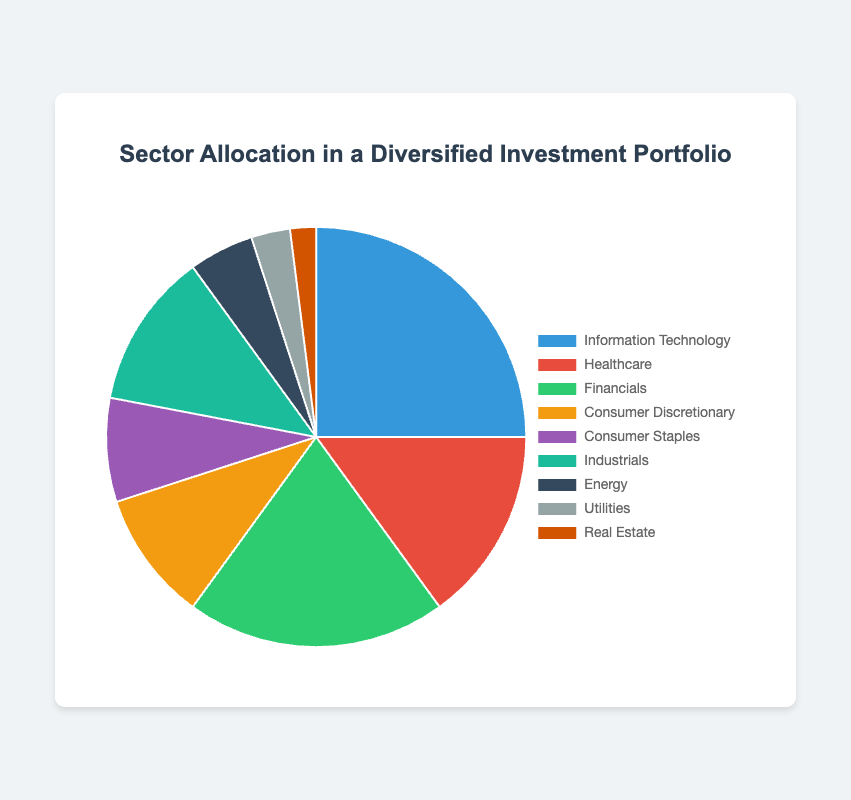What is the sector with the highest allocation percentage? The sector with the highest allocation percentage can be identified by looking at the largest segment in the pie chart. "Information Technology" has the largest slice, indicating 25%.
Answer: Information Technology Which sectors together make up more than 50% of the portfolio? Summing the top sectors by their allocation percentages: Information Technology (25%) + Financials (20%) + Healthcare (15%) = 60%. This sum surpasses 50%, indicating these three sectors together make up more than half of the portfolio.
Answer: Information Technology, Financials, Healthcare What is the difference in allocation between Consumer Discretionary and Consumer Staples? Subtract the allocation percentage of Consumer Staples (8%) from Consumer Discretionary (10%) to find the difference: 10% - 8% = 2%.
Answer: 2% Compare the allocation percentages of Energy and Utilities. Which one is higher and by how much? Energy has an allocation percentage of 5%, and Utilities has 3%. Subtracting the two: 5% - 3% = 2%. Energy has a higher allocation by 2%.
Answer: Energy by 2% What is the total allocation percentage for sectors under 10%? Identifying sectors with allocation percentages under 10% and summing them: Consumer Discretionary (10%) + Consumer Staples (8%) + Energy (5%) + Utilities (3%) + Real Estate (2%) = 10% + 8% + 5% + 3% + 2% = 28%.
Answer: 28% What is the combined allocation percentage of Industrials and Real Estate? Add the allocation percentages of Industrials (12%) and Real Estate (2%): 12% + 2% = 14%.
Answer: 14% Which sector has the smallest allocation and what is its percentage? The smallest sector can be identified by finding the smallest segment in the pie chart. "Real Estate" has the smallest slice, indicating an allocation of 2%.
Answer: Real Estate, 2% By how much does Financials outpace Healthcare in terms of allocation percentage? Financials have a 20% allocation whereas Healthcare has 15%. The difference is 20% - 15% = 5%.
Answer: 5% If the allocation for Energy were to increase by 2%, what would its new allocation percentage be? Current allocation for Energy is 5%. Adding 2% to this results in 5% + 2% = 7%.
Answer: 7% 